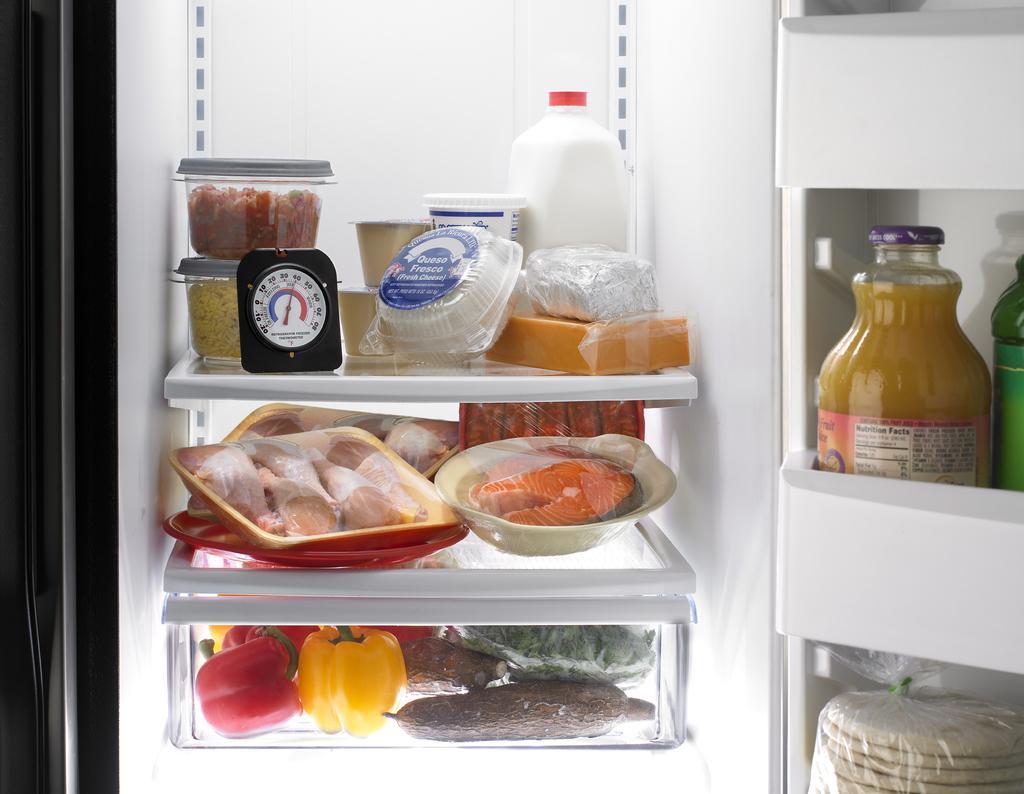How would you summarize this image in a sentence or two? In this picture we can see boxes, vegetables, bottles, food items and objects in the refrigerator. 